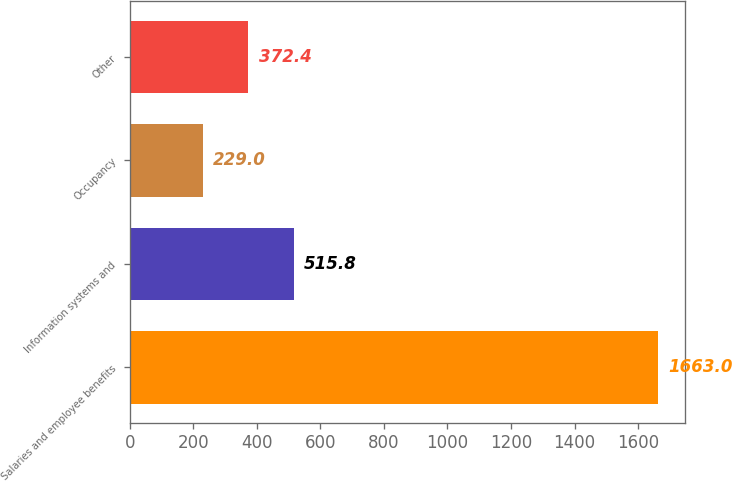<chart> <loc_0><loc_0><loc_500><loc_500><bar_chart><fcel>Salaries and employee benefits<fcel>Information systems and<fcel>Occupancy<fcel>Other<nl><fcel>1663<fcel>515.8<fcel>229<fcel>372.4<nl></chart> 